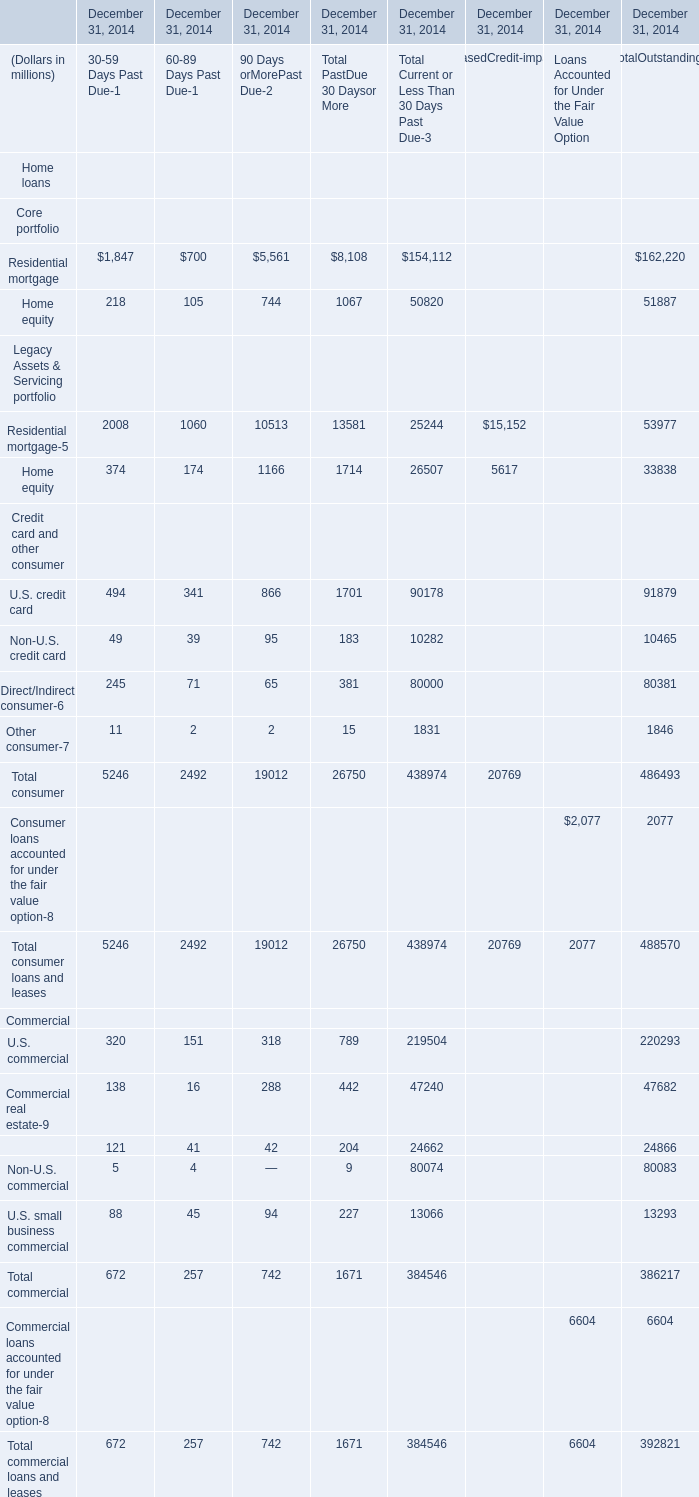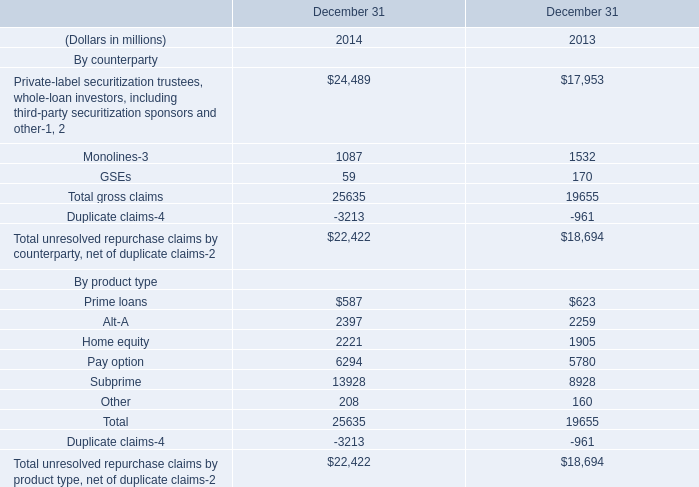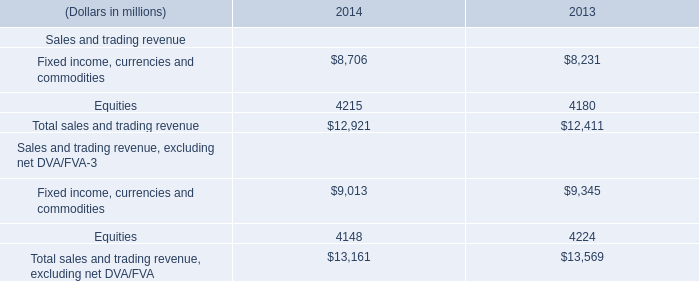What's the current or Less Than 30 Days Past Due growth rate of Total loans and leases,in contrast with Total Past Due 30 Days or More? 
Computations: ((823520 - 28421) / 28421)
Answer: 27.97576. 